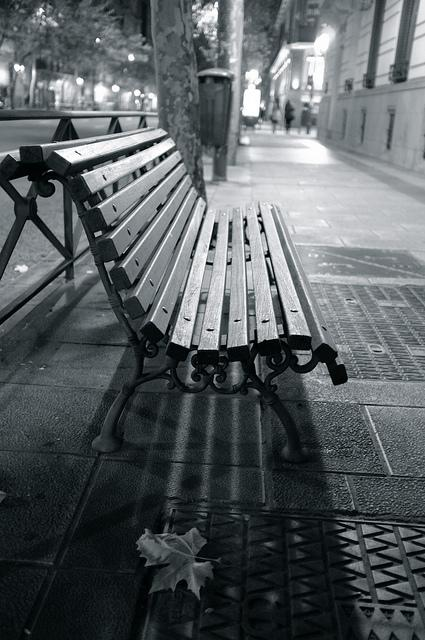In what area is this chair located? sidewalk 